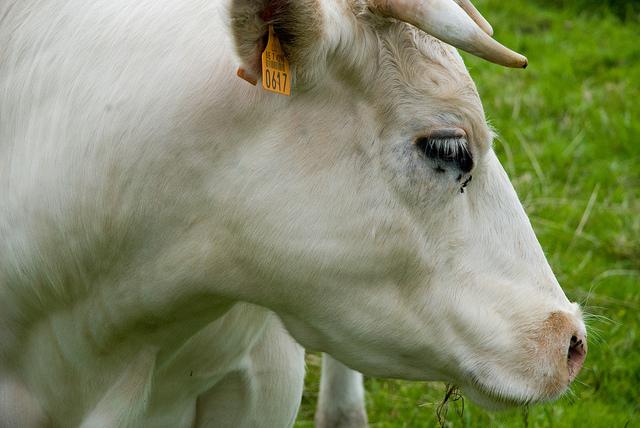Does this animal belong to someone?
Quick response, please. Yes. Which direction is the cow looking?
Give a very brief answer. Right. What color is the cow?
Answer briefly. White. Is the tag held on by magnets?
Quick response, please. No. 